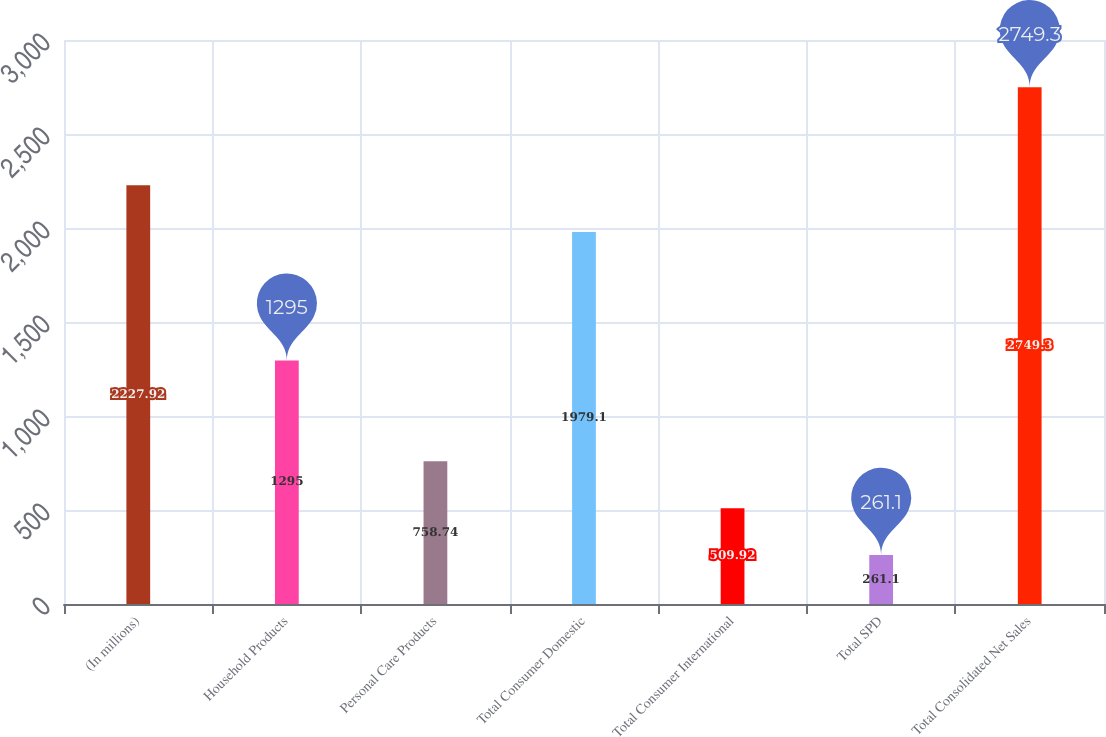Convert chart. <chart><loc_0><loc_0><loc_500><loc_500><bar_chart><fcel>(In millions)<fcel>Household Products<fcel>Personal Care Products<fcel>Total Consumer Domestic<fcel>Total Consumer International<fcel>Total SPD<fcel>Total Consolidated Net Sales<nl><fcel>2227.92<fcel>1295<fcel>758.74<fcel>1979.1<fcel>509.92<fcel>261.1<fcel>2749.3<nl></chart> 